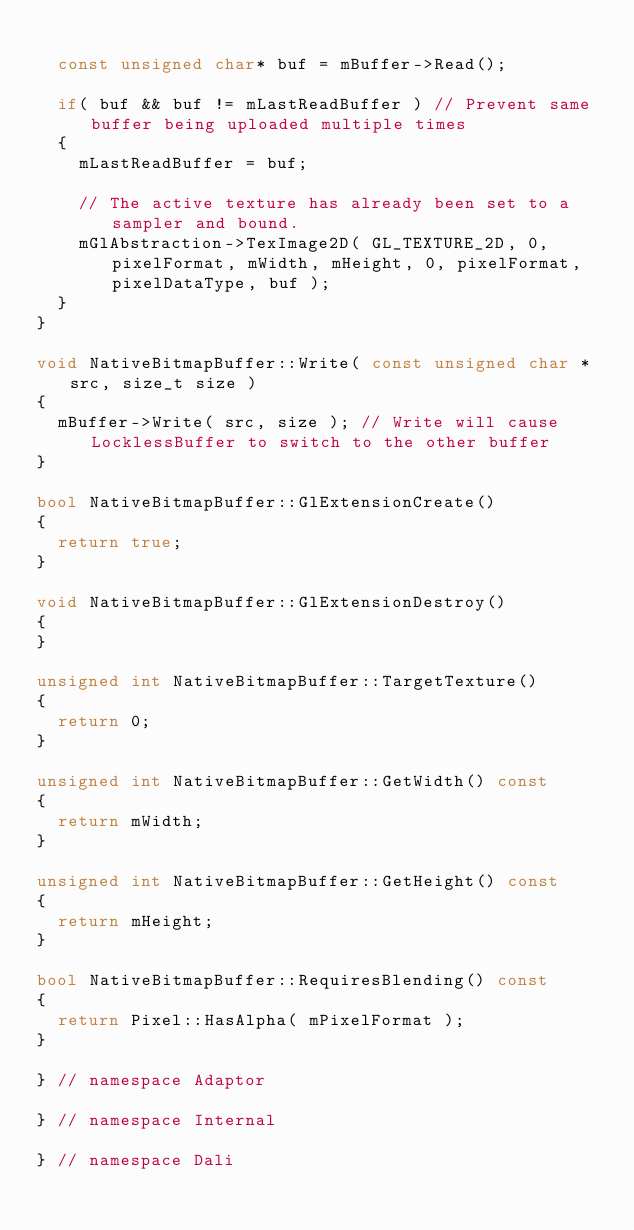<code> <loc_0><loc_0><loc_500><loc_500><_C++_>
  const unsigned char* buf = mBuffer->Read();

  if( buf && buf != mLastReadBuffer ) // Prevent same buffer being uploaded multiple times
  {
    mLastReadBuffer = buf;

    // The active texture has already been set to a sampler and bound.
    mGlAbstraction->TexImage2D( GL_TEXTURE_2D, 0, pixelFormat, mWidth, mHeight, 0, pixelFormat, pixelDataType, buf );
  }
}

void NativeBitmapBuffer::Write( const unsigned char *src, size_t size )
{
  mBuffer->Write( src, size ); // Write will cause LocklessBuffer to switch to the other buffer
}

bool NativeBitmapBuffer::GlExtensionCreate()
{
  return true;
}

void NativeBitmapBuffer::GlExtensionDestroy()
{
}

unsigned int NativeBitmapBuffer::TargetTexture()
{
  return 0;
}

unsigned int NativeBitmapBuffer::GetWidth() const
{
  return mWidth;
}

unsigned int NativeBitmapBuffer::GetHeight() const
{
  return mHeight;
}

bool NativeBitmapBuffer::RequiresBlending() const
{
  return Pixel::HasAlpha( mPixelFormat );
}

} // namespace Adaptor

} // namespace Internal

} // namespace Dali
</code> 